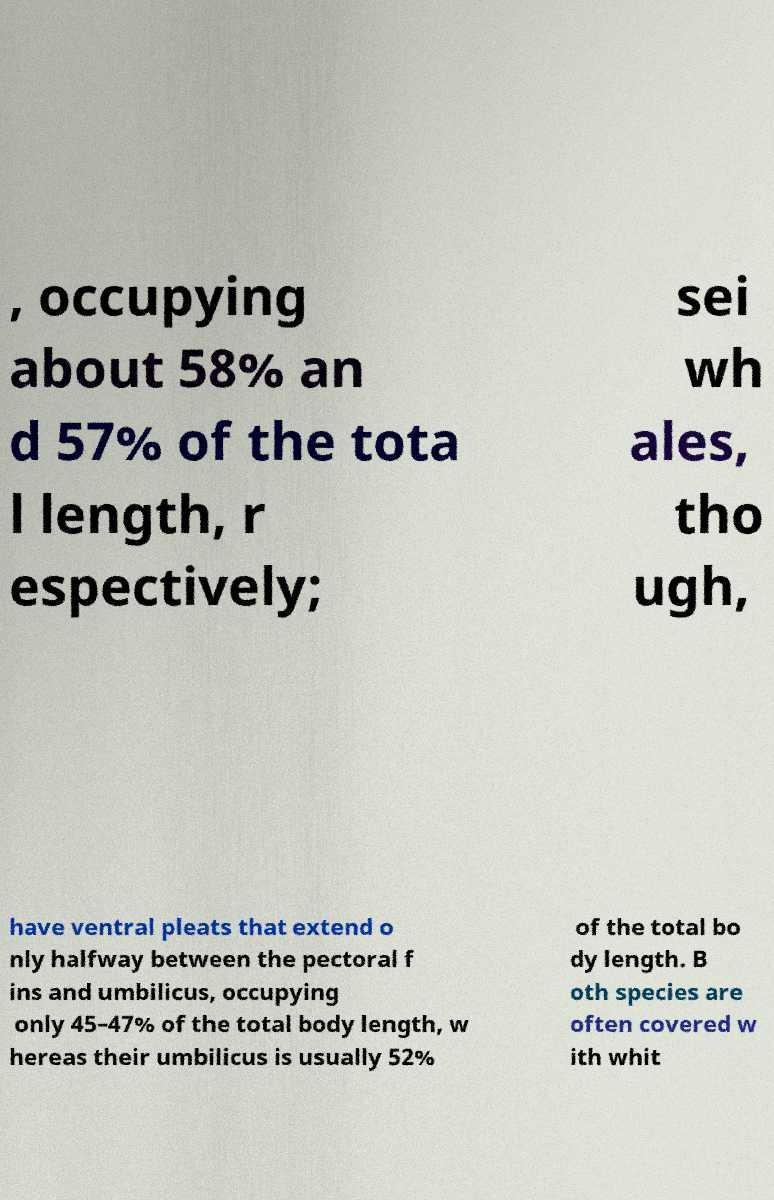What messages or text are displayed in this image? I need them in a readable, typed format. , occupying about 58% an d 57% of the tota l length, r espectively; sei wh ales, tho ugh, have ventral pleats that extend o nly halfway between the pectoral f ins and umbilicus, occupying only 45–47% of the total body length, w hereas their umbilicus is usually 52% of the total bo dy length. B oth species are often covered w ith whit 